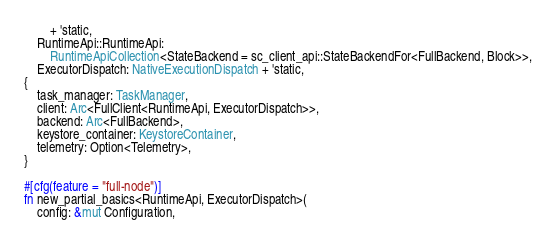Convert code to text. <code><loc_0><loc_0><loc_500><loc_500><_Rust_>		+ 'static,
	RuntimeApi::RuntimeApi:
		RuntimeApiCollection<StateBackend = sc_client_api::StateBackendFor<FullBackend, Block>>,
	ExecutorDispatch: NativeExecutionDispatch + 'static,
{
	task_manager: TaskManager,
	client: Arc<FullClient<RuntimeApi, ExecutorDispatch>>,
	backend: Arc<FullBackend>,
	keystore_container: KeystoreContainer,
	telemetry: Option<Telemetry>,
}

#[cfg(feature = "full-node")]
fn new_partial_basics<RuntimeApi, ExecutorDispatch>(
	config: &mut Configuration,</code> 